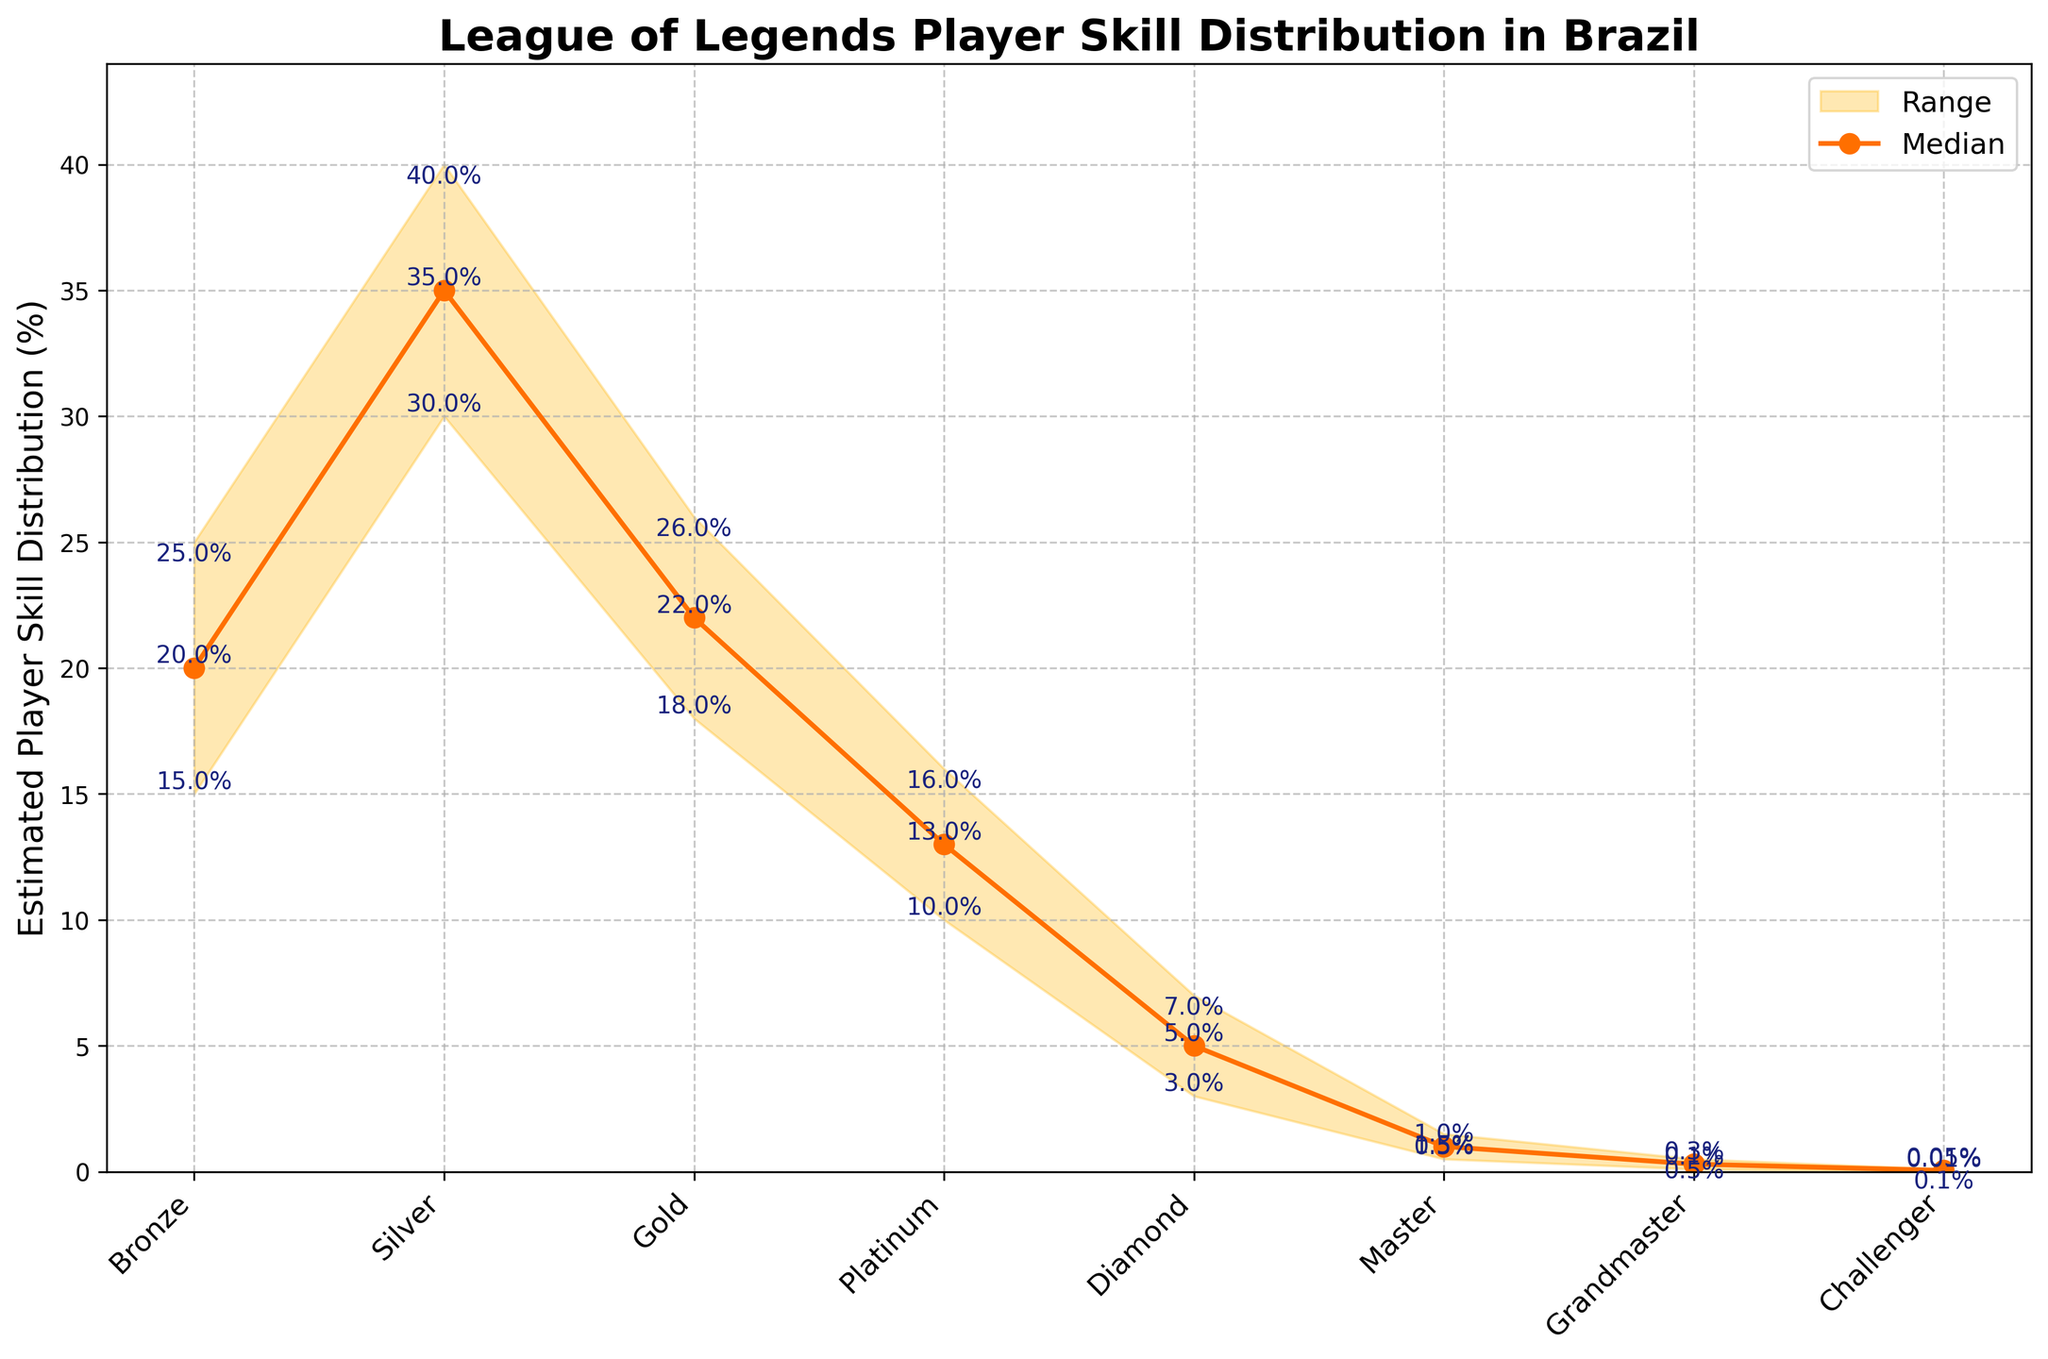What is the title of the figure? The title of the figure is usually displayed at the top of the chart. In this case, it can be identified directly from the visual content.
Answer: League of Legends Player Skill Distribution in Brazil What are the player skill ranks listed on the x-axis? To find the player skill ranks, look to the labels on the x-axis of the chart. Each rank will be listed there.
Answer: Bronze, Silver, Gold, Platinum, Diamond, Master, Grandmaster, Challenger What is the median estimated skill distribution for Silver rank? Locate the Silver rank on the x-axis, and then look at the plotted median value point above it. The percentage should be displayed near this point.
Answer: 35% Which rank has the lowest upper limit in the estimated skill distribution? Survey the upper limit values for each rank and identify the smallest one.
Answer: Challenger By how much does the median estimated skill distribution for Gold exceed that of Diamond? Identify the median values for both Gold and Diamond, and then subtract the median value for Diamond from that of Gold.
Answer: 22% - 5% = 17% What is the skill distribution range for Platinum rank? The skill distribution range is the difference between the upper and lower limits for Platinum rank. Subtract the lower limit from the upper limit to get this range.
Answer: 16% - 10% = 6% In which rank's skill distribution is the difference between the lower and upper limits the largest? Compare the ranges (upper limit minus lower limit) for all ranks, and identify the one with the largest range.
Answer: Silver How does the median value for Master compare to that of Bronze? Compare the median values plotted for Master and Bronze, and describe how they relate to each other.
Answer: The median value for Master (1%) is significantly lower than that for Bronze (20%) Is the median skill distribution for Platinum higher than the lower limit for Gold? Compare the median value of Platinum to the lower limit of Gold, by locating both values on the chart.
Answer: Yes, 13% > 18% Look at the color coding in the fan chart. What color represents the range, and what color represents the median? Identify the colors used in the chart by matching the elements (range and median) to their respective colors.
Answer: Range: light orange, Median: dark orange 